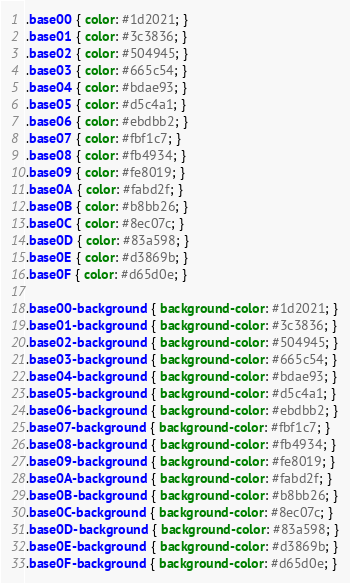<code> <loc_0><loc_0><loc_500><loc_500><_CSS_>.base00 { color: #1d2021; }
.base01 { color: #3c3836; }
.base02 { color: #504945; }
.base03 { color: #665c54; }
.base04 { color: #bdae93; }
.base05 { color: #d5c4a1; }
.base06 { color: #ebdbb2; }
.base07 { color: #fbf1c7; }
.base08 { color: #fb4934; }
.base09 { color: #fe8019; }
.base0A { color: #fabd2f; }
.base0B { color: #b8bb26; }
.base0C { color: #8ec07c; }
.base0D { color: #83a598; }
.base0E { color: #d3869b; }
.base0F { color: #d65d0e; }

.base00-background { background-color: #1d2021; }
.base01-background { background-color: #3c3836; }
.base02-background { background-color: #504945; }
.base03-background { background-color: #665c54; }
.base04-background { background-color: #bdae93; }
.base05-background { background-color: #d5c4a1; }
.base06-background { background-color: #ebdbb2; }
.base07-background { background-color: #fbf1c7; }
.base08-background { background-color: #fb4934; }
.base09-background { background-color: #fe8019; }
.base0A-background { background-color: #fabd2f; }
.base0B-background { background-color: #b8bb26; }
.base0C-background { background-color: #8ec07c; }
.base0D-background { background-color: #83a598; }
.base0E-background { background-color: #d3869b; }
.base0F-background { background-color: #d65d0e; }
</code> 